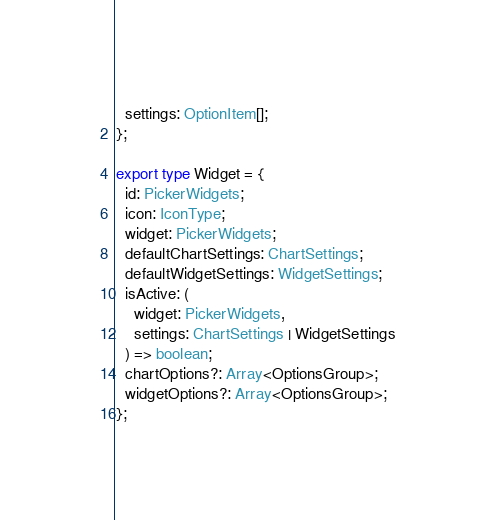<code> <loc_0><loc_0><loc_500><loc_500><_TypeScript_>  settings: OptionItem[];
};

export type Widget = {
  id: PickerWidgets;
  icon: IconType;
  widget: PickerWidgets;
  defaultChartSettings: ChartSettings;
  defaultWidgetSettings: WidgetSettings;
  isActive: (
    widget: PickerWidgets,
    settings: ChartSettings | WidgetSettings
  ) => boolean;
  chartOptions?: Array<OptionsGroup>;
  widgetOptions?: Array<OptionsGroup>;
};
</code> 